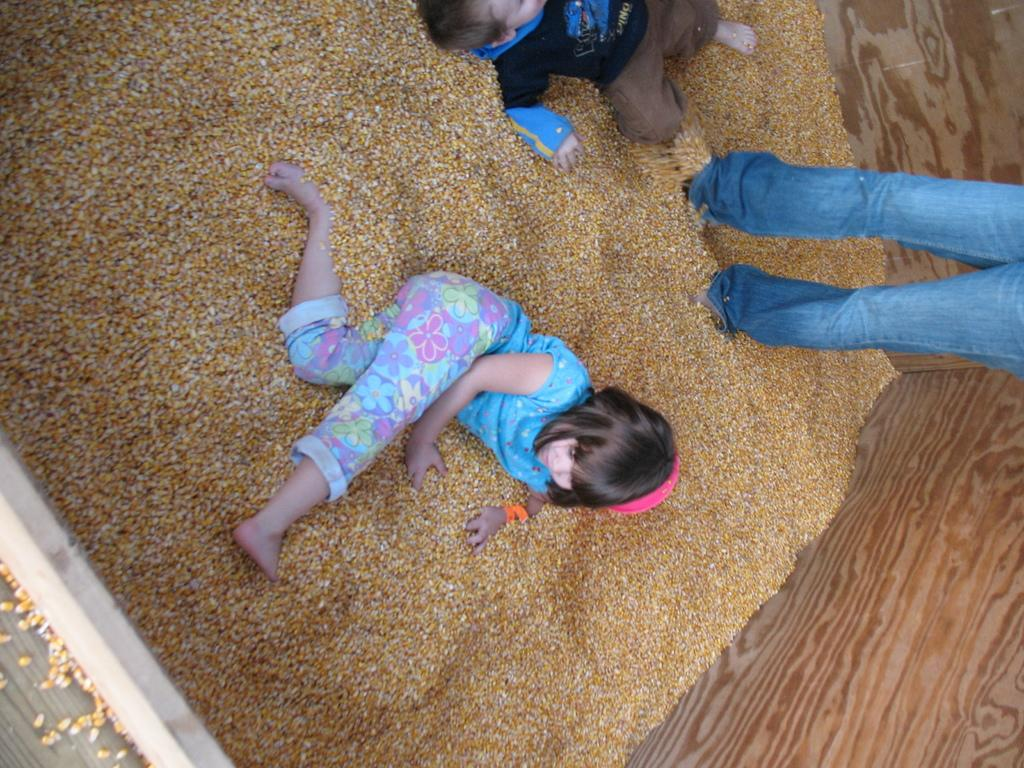How many children are playing in the sand in the image? There are two children in the sand in the image. Is there anyone else present near the children? Yes, there is a person standing near the children. What type of barrier surrounds the sand area? There is a wooden wall around the sand. What type of cork can be seen floating in the sand in the image? There is no cork present in the image; it features two children playing in the sand with a person standing nearby and a wooden wall surrounding the area. 